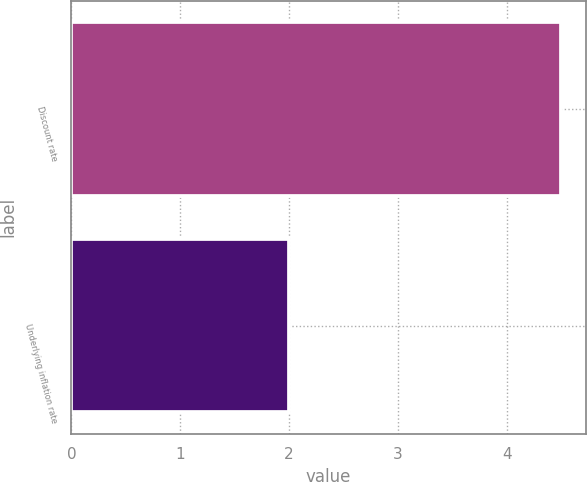<chart> <loc_0><loc_0><loc_500><loc_500><bar_chart><fcel>Discount rate<fcel>Underlying inflation rate<nl><fcel>4.5<fcel>2<nl></chart> 